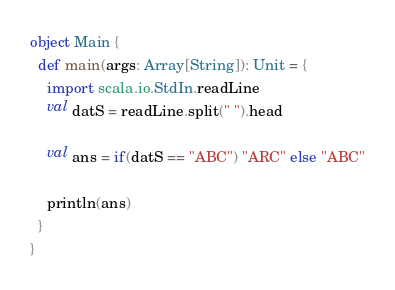Convert code to text. <code><loc_0><loc_0><loc_500><loc_500><_Scala_>object Main {
  def main(args: Array[String]): Unit = {
    import scala.io.StdIn.readLine
    val datS = readLine.split(" ").head

    val ans = if(datS == "ABC") "ARC" else "ABC"

    println(ans)
  }
}
</code> 